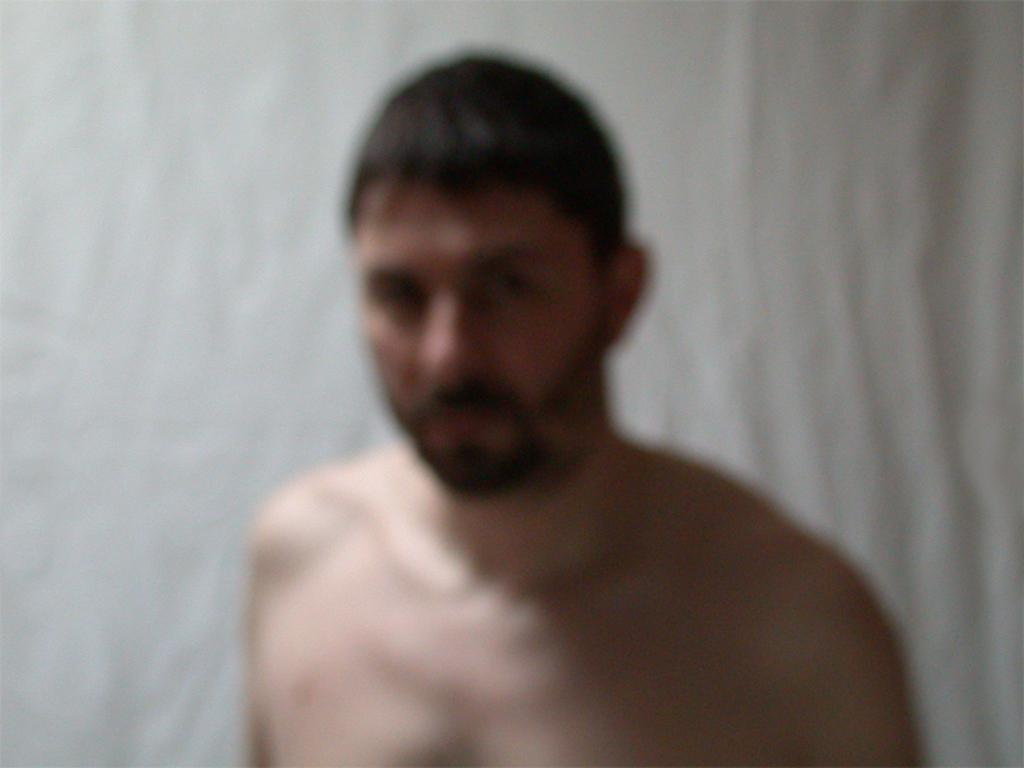What is the main subject in the foreground of the image? There is a person in the foreground of the image. What can be seen in the background of the image? There is a wall in the background of the image. What type of argument is taking place between the person and the bulb in the image? There is no bulb present in the image, and therefore no argument can be observed. 